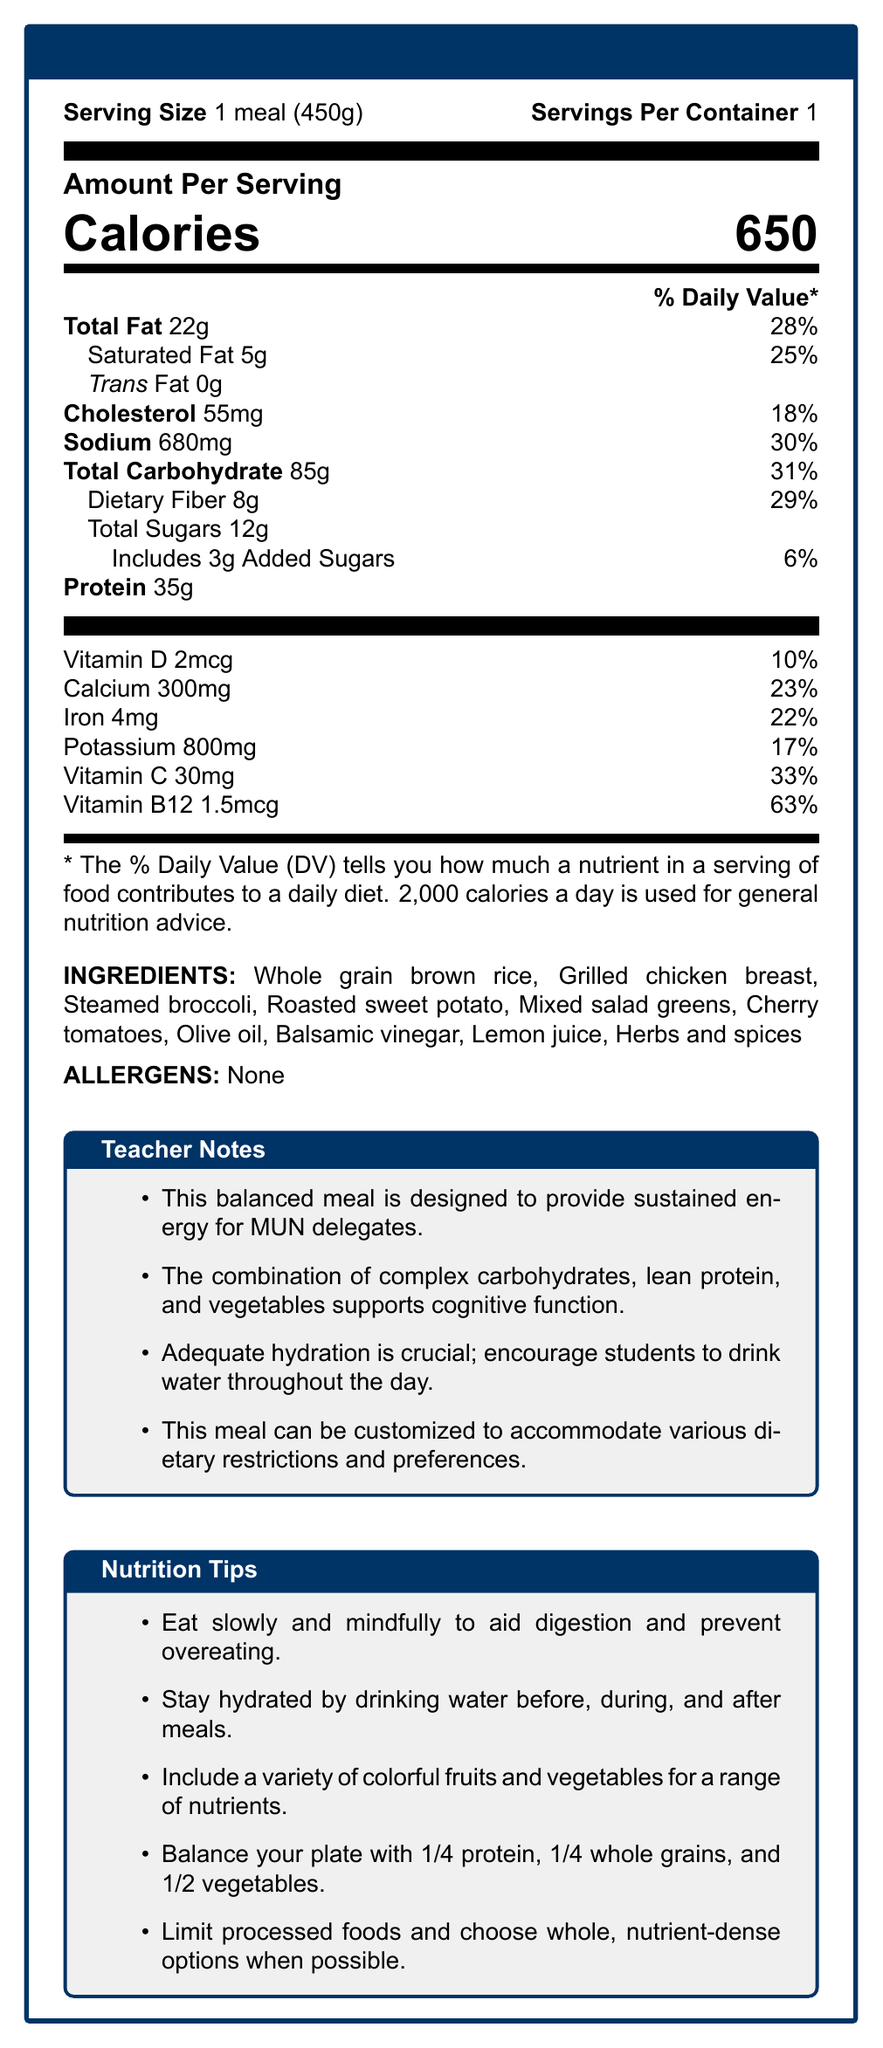what is the serving size for the MUNutrition Delegate Meal? The serving size is listed as "1 meal (450g)" in the document.
Answer: 1 meal (450g) how many calories are in one serving of the MUNutrition Delegate Meal? The document states that one serving contains 650 calories.
Answer: 650 calories what percentage of the daily value of sodium does the MUNutrition Delegate Meal contain? It is specified in the document that the meal contains 30% of the daily value for sodium.
Answer: 30% how much dietary fiber is in the MUNutrition Delegate Meal? The document shows that the dietary fiber content is 8g.
Answer: 8g which ingredient in the MUNutrition Delegate Meal is a source of protein? The grilled chicken breast is mentioned as an ingredient and is a known source of protein.
Answer: Grilled chicken breast which nutrient has the highest percentage of the daily value in the MUNutrition Delegate Meal? A. Vitamin D B. Calcium C. Vitamin B12 D. Iron The document mentions that Vitamin B12 has a daily value percentage of 63%, which is the highest among the listed nutrients.
Answer: C. Vitamin B12 what are the main components of this meal? A. Proteins, Dairy, Fruits B. Carbohydrates, Proteins, Vegetables C. Sugars, Fats, Minerals D. Fibers, Sugars, Oils The meal includes whole grain brown rice (carbohydrates), grilled chicken breast (protein), and various vegetables.
Answer: B. Carbohydrates, Proteins, Vegetables does the MUNutrition Delegate Meal contain any trans fat? The trans fat content is listed as 0g in the document.
Answer: No summarize the main purpose of the MUNutrition Delegate Meal. The meal is designed to offer balanced nutrition with complex carbohydrates, lean protein, and vegetables, to ensure sustained energy and cognitive support for MUN delegates.
Answer: Provide sustained energy and support cognitive function for MUN delegates. what is the total amount of sugars in the meal, including added sugars? The total sugars amount is 12g, which includes 3g of added sugars.
Answer: 12g is this meal allergen-free? The document states that there are no allergens in the meal.
Answer: Yes what is the main idea of the teacher's notes section? The notes emphasize the meal's balance for energy and cognitive benefits, the importance of hydration, and the ability to customize the meal for different dietary needs.
Answer: The meal is designed to provide sustained energy and support cognitive function. Hydration is important, and customization is possible. how can one balance their plate according to the nutrition tips? A. 1/3 protein, 1/3 grains, 1/3 vegetables B. 1/2 protein, 1/4 whole grains, 1/4 vegetables C. 1/4 protein, 1/4 whole grains, 1/2 vegetables D. 1/3 protein, 1/4 grains, 1/3 oils The nutrition tips suggest a plate balance of 1/4 protein, 1/4 whole grains, and 1/2 vegetables.
Answer: C. 1/4 protein, 1/4 whole grains, 1/2 vegetables what is the percentage of the daily value for vitamin C in the meal? The document lists the daily value percentage for vitamin C as 33%.
Answer: 33% what are some of the ingredients used to flavor the meal? The document lists these ingredients as part of the meal.
Answer: Olive oil, Balsamic vinegar, Lemon juice, Herbs and spices what is the daily value percentage of iron in the MUNutrition Delegate Meal? The document specifies that the meal provides 22% of the daily value for iron.
Answer: 22% how much protein does one serving of the MUNutrition Delegate Meal contain? The document states that there are 35g of protein per serving.
Answer: 35g how much vitamin D is in the MUNutrition Delegate Meal? The amount of vitamin D in the meal is 2mcg as stated in the document.
Answer: 2mcg what are the tips provided for staying hydrated? The nutrition tips section advises drinking water before, during, and after meals.
Answer: Drink water before, during, and after meals. what is the specific reason for including complex carbohydrates in the meal? The teacher notes mention that complex carbohydrates help support cognitive function.
Answer: Supports cognitive function. is the exact recipe for the MUNutrition Delegate Meal provided? The document provides the ingredients but does not include the exact recipe or cooking instructions.
Answer: Cannot be determined 